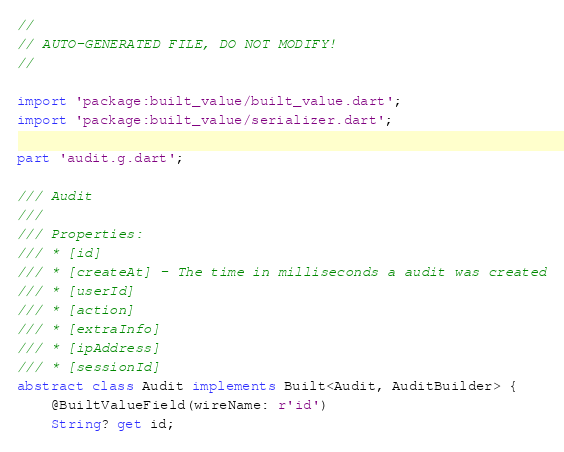Convert code to text. <code><loc_0><loc_0><loc_500><loc_500><_Dart_>//
// AUTO-GENERATED FILE, DO NOT MODIFY!
//

import 'package:built_value/built_value.dart';
import 'package:built_value/serializer.dart';

part 'audit.g.dart';

/// Audit
///
/// Properties:
/// * [id] 
/// * [createAt] - The time in milliseconds a audit was created
/// * [userId] 
/// * [action] 
/// * [extraInfo] 
/// * [ipAddress] 
/// * [sessionId] 
abstract class Audit implements Built<Audit, AuditBuilder> {
    @BuiltValueField(wireName: r'id')
    String? get id;
</code> 